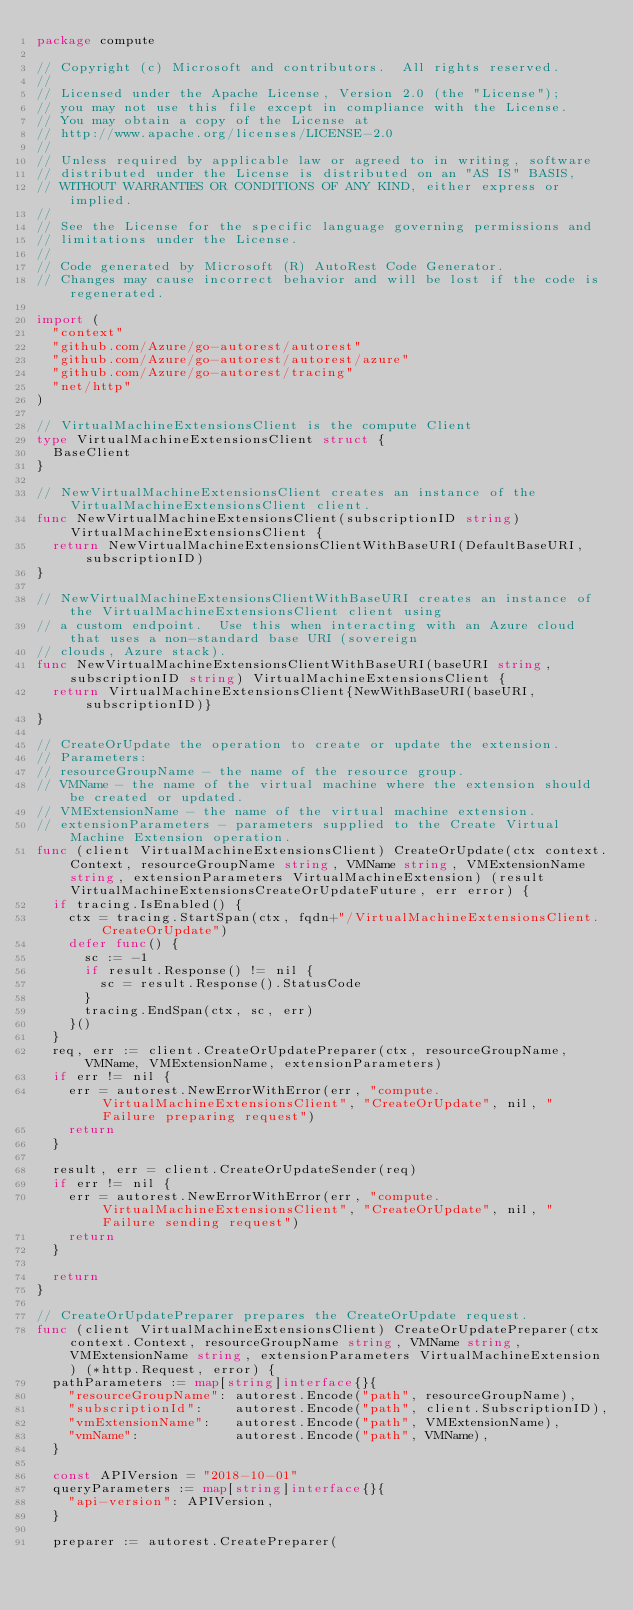Convert code to text. <code><loc_0><loc_0><loc_500><loc_500><_Go_>package compute

// Copyright (c) Microsoft and contributors.  All rights reserved.
//
// Licensed under the Apache License, Version 2.0 (the "License");
// you may not use this file except in compliance with the License.
// You may obtain a copy of the License at
// http://www.apache.org/licenses/LICENSE-2.0
//
// Unless required by applicable law or agreed to in writing, software
// distributed under the License is distributed on an "AS IS" BASIS,
// WITHOUT WARRANTIES OR CONDITIONS OF ANY KIND, either express or implied.
//
// See the License for the specific language governing permissions and
// limitations under the License.
//
// Code generated by Microsoft (R) AutoRest Code Generator.
// Changes may cause incorrect behavior and will be lost if the code is regenerated.

import (
	"context"
	"github.com/Azure/go-autorest/autorest"
	"github.com/Azure/go-autorest/autorest/azure"
	"github.com/Azure/go-autorest/tracing"
	"net/http"
)

// VirtualMachineExtensionsClient is the compute Client
type VirtualMachineExtensionsClient struct {
	BaseClient
}

// NewVirtualMachineExtensionsClient creates an instance of the VirtualMachineExtensionsClient client.
func NewVirtualMachineExtensionsClient(subscriptionID string) VirtualMachineExtensionsClient {
	return NewVirtualMachineExtensionsClientWithBaseURI(DefaultBaseURI, subscriptionID)
}

// NewVirtualMachineExtensionsClientWithBaseURI creates an instance of the VirtualMachineExtensionsClient client using
// a custom endpoint.  Use this when interacting with an Azure cloud that uses a non-standard base URI (sovereign
// clouds, Azure stack).
func NewVirtualMachineExtensionsClientWithBaseURI(baseURI string, subscriptionID string) VirtualMachineExtensionsClient {
	return VirtualMachineExtensionsClient{NewWithBaseURI(baseURI, subscriptionID)}
}

// CreateOrUpdate the operation to create or update the extension.
// Parameters:
// resourceGroupName - the name of the resource group.
// VMName - the name of the virtual machine where the extension should be created or updated.
// VMExtensionName - the name of the virtual machine extension.
// extensionParameters - parameters supplied to the Create Virtual Machine Extension operation.
func (client VirtualMachineExtensionsClient) CreateOrUpdate(ctx context.Context, resourceGroupName string, VMName string, VMExtensionName string, extensionParameters VirtualMachineExtension) (result VirtualMachineExtensionsCreateOrUpdateFuture, err error) {
	if tracing.IsEnabled() {
		ctx = tracing.StartSpan(ctx, fqdn+"/VirtualMachineExtensionsClient.CreateOrUpdate")
		defer func() {
			sc := -1
			if result.Response() != nil {
				sc = result.Response().StatusCode
			}
			tracing.EndSpan(ctx, sc, err)
		}()
	}
	req, err := client.CreateOrUpdatePreparer(ctx, resourceGroupName, VMName, VMExtensionName, extensionParameters)
	if err != nil {
		err = autorest.NewErrorWithError(err, "compute.VirtualMachineExtensionsClient", "CreateOrUpdate", nil, "Failure preparing request")
		return
	}

	result, err = client.CreateOrUpdateSender(req)
	if err != nil {
		err = autorest.NewErrorWithError(err, "compute.VirtualMachineExtensionsClient", "CreateOrUpdate", nil, "Failure sending request")
		return
	}

	return
}

// CreateOrUpdatePreparer prepares the CreateOrUpdate request.
func (client VirtualMachineExtensionsClient) CreateOrUpdatePreparer(ctx context.Context, resourceGroupName string, VMName string, VMExtensionName string, extensionParameters VirtualMachineExtension) (*http.Request, error) {
	pathParameters := map[string]interface{}{
		"resourceGroupName": autorest.Encode("path", resourceGroupName),
		"subscriptionId":    autorest.Encode("path", client.SubscriptionID),
		"vmExtensionName":   autorest.Encode("path", VMExtensionName),
		"vmName":            autorest.Encode("path", VMName),
	}

	const APIVersion = "2018-10-01"
	queryParameters := map[string]interface{}{
		"api-version": APIVersion,
	}

	preparer := autorest.CreatePreparer(</code> 